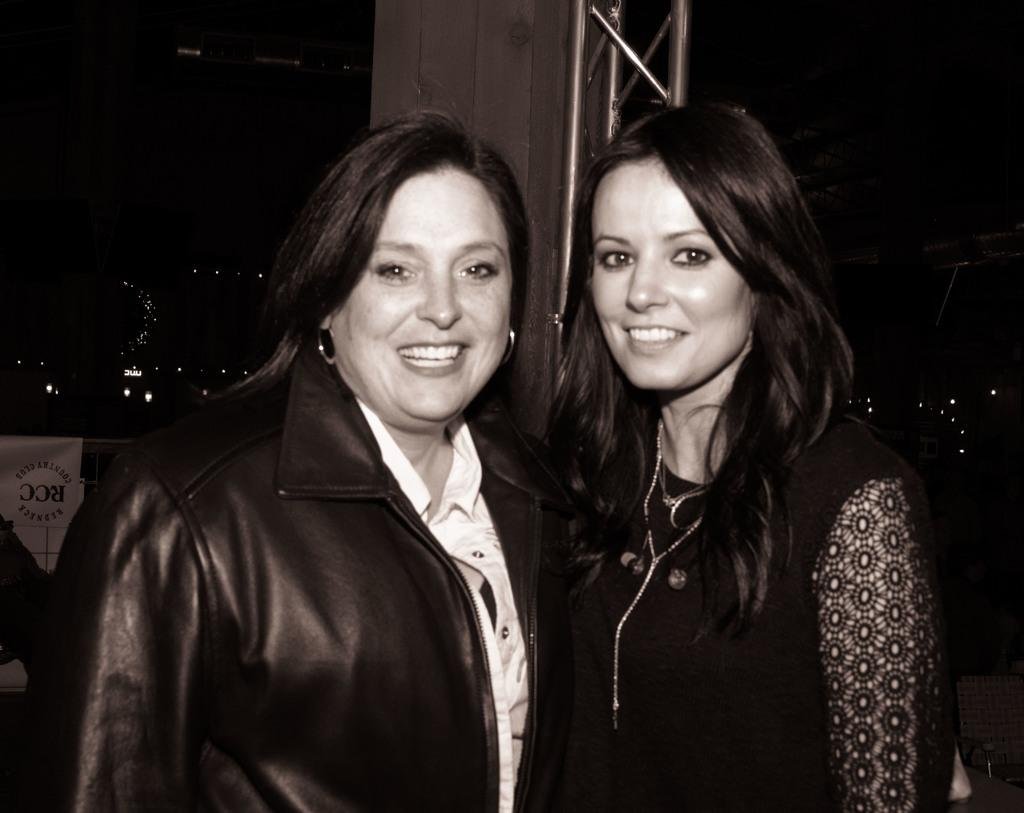How many people are in the image? There are two ladies in the image. What are the ladies doing in the image? The ladies are standing and smiling. What can be seen in the background of the image? There is a pillar in the background of the image. What is on the left side of the image? There is a banner on the left side of the image. What can be seen illuminating the scene in the image? There are lights visible in the image. What type of lace can be seen on the ladies' clothing in the image? There is no lace visible on the ladies' clothing in the image. Can you describe the wilderness surrounding the ladies in the image? There is no wilderness present in the image; it appears to be a more urban setting. 